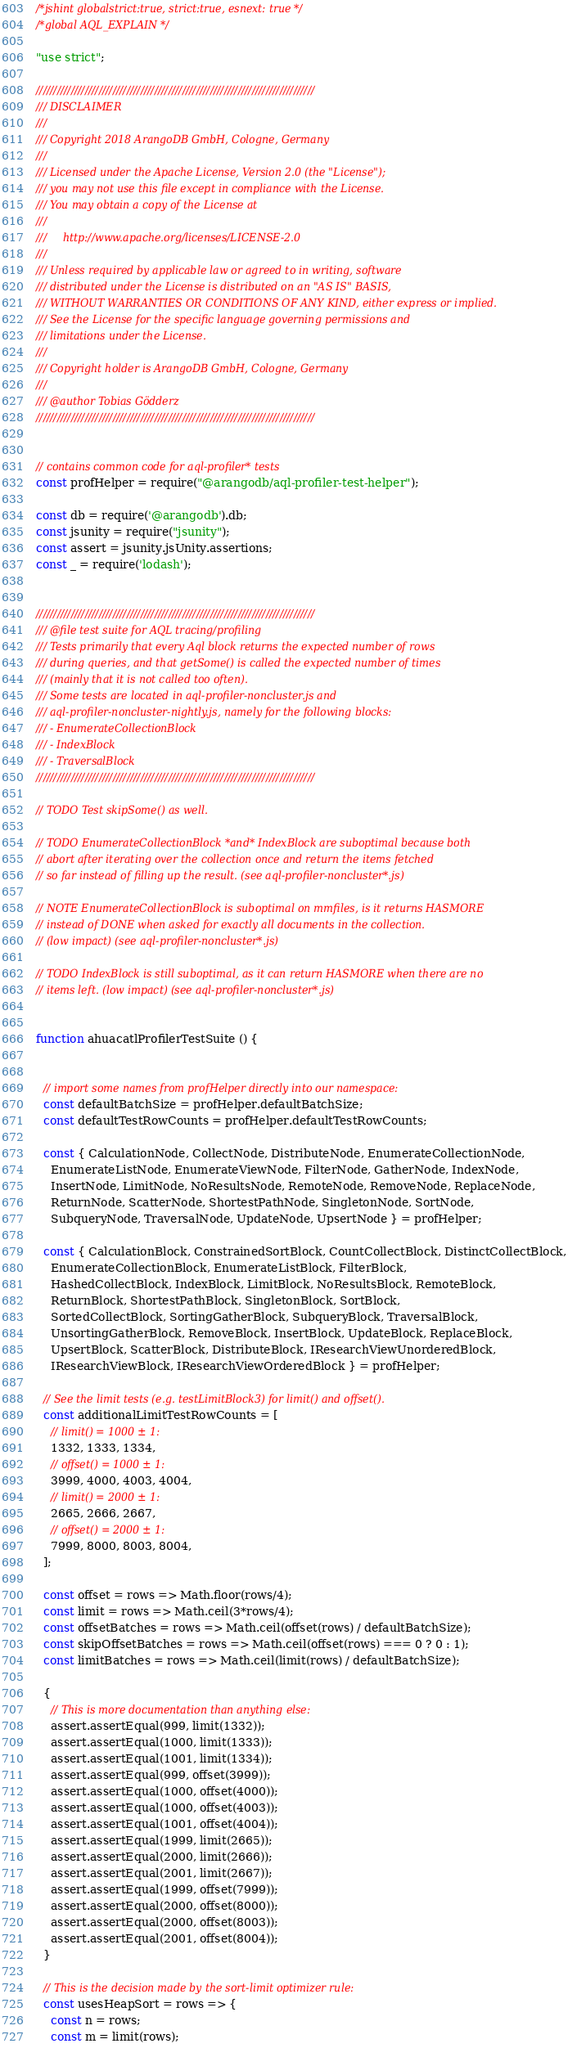Convert code to text. <code><loc_0><loc_0><loc_500><loc_500><_JavaScript_>/*jshint globalstrict:true, strict:true, esnext: true */
/*global AQL_EXPLAIN */

"use strict";

////////////////////////////////////////////////////////////////////////////////
/// DISCLAIMER
///
/// Copyright 2018 ArangoDB GmbH, Cologne, Germany
///
/// Licensed under the Apache License, Version 2.0 (the "License");
/// you may not use this file except in compliance with the License.
/// You may obtain a copy of the License at
///
///     http://www.apache.org/licenses/LICENSE-2.0
///
/// Unless required by applicable law or agreed to in writing, software
/// distributed under the License is distributed on an "AS IS" BASIS,
/// WITHOUT WARRANTIES OR CONDITIONS OF ANY KIND, either express or implied.
/// See the License for the specific language governing permissions and
/// limitations under the License.
///
/// Copyright holder is ArangoDB GmbH, Cologne, Germany
///
/// @author Tobias Gödderz
////////////////////////////////////////////////////////////////////////////////


// contains common code for aql-profiler* tests
const profHelper = require("@arangodb/aql-profiler-test-helper");

const db = require('@arangodb').db;
const jsunity = require("jsunity");
const assert = jsunity.jsUnity.assertions;
const _ = require('lodash');


////////////////////////////////////////////////////////////////////////////////
/// @file test suite for AQL tracing/profiling
/// Tests primarily that every Aql block returns the expected number of rows
/// during queries, and that getSome() is called the expected number of times
/// (mainly that it is not called too often).
/// Some tests are located in aql-profiler-noncluster.js and
/// aql-profiler-noncluster-nightly.js, namely for the following blocks:
/// - EnumerateCollectionBlock
/// - IndexBlock
/// - TraversalBlock
////////////////////////////////////////////////////////////////////////////////

// TODO Test skipSome() as well.

// TODO EnumerateCollectionBlock *and* IndexBlock are suboptimal because both
// abort after iterating over the collection once and return the items fetched
// so far instead of filling up the result. (see aql-profiler-noncluster*.js)

// NOTE EnumerateCollectionBlock is suboptimal on mmfiles, is it returns HASMORE
// instead of DONE when asked for exactly all documents in the collection.
// (low impact) (see aql-profiler-noncluster*.js)

// TODO IndexBlock is still suboptimal, as it can return HASMORE when there are no
// items left. (low impact) (see aql-profiler-noncluster*.js)


function ahuacatlProfilerTestSuite () {


  // import some names from profHelper directly into our namespace:
  const defaultBatchSize = profHelper.defaultBatchSize;
  const defaultTestRowCounts = profHelper.defaultTestRowCounts;

  const { CalculationNode, CollectNode, DistributeNode, EnumerateCollectionNode,
    EnumerateListNode, EnumerateViewNode, FilterNode, GatherNode, IndexNode,
    InsertNode, LimitNode, NoResultsNode, RemoteNode, RemoveNode, ReplaceNode,
    ReturnNode, ScatterNode, ShortestPathNode, SingletonNode, SortNode,
    SubqueryNode, TraversalNode, UpdateNode, UpsertNode } = profHelper;

  const { CalculationBlock, ConstrainedSortBlock, CountCollectBlock, DistinctCollectBlock,
    EnumerateCollectionBlock, EnumerateListBlock, FilterBlock,
    HashedCollectBlock, IndexBlock, LimitBlock, NoResultsBlock, RemoteBlock,
    ReturnBlock, ShortestPathBlock, SingletonBlock, SortBlock,
    SortedCollectBlock, SortingGatherBlock, SubqueryBlock, TraversalBlock,
    UnsortingGatherBlock, RemoveBlock, InsertBlock, UpdateBlock, ReplaceBlock,
    UpsertBlock, ScatterBlock, DistributeBlock, IResearchViewUnorderedBlock,
    IResearchViewBlock, IResearchViewOrderedBlock } = profHelper;

  // See the limit tests (e.g. testLimitBlock3) for limit() and offset().
  const additionalLimitTestRowCounts = [
    // limit() = 1000 ± 1:
    1332, 1333, 1334,
    // offset() = 1000 ± 1:
    3999, 4000, 4003, 4004,
    // limit() = 2000 ± 1:
    2665, 2666, 2667,
    // offset() = 2000 ± 1:
    7999, 8000, 8003, 8004,
  ];

  const offset = rows => Math.floor(rows/4);
  const limit = rows => Math.ceil(3*rows/4);
  const offsetBatches = rows => Math.ceil(offset(rows) / defaultBatchSize);
  const skipOffsetBatches = rows => Math.ceil(offset(rows) === 0 ? 0 : 1);
  const limitBatches = rows => Math.ceil(limit(rows) / defaultBatchSize);

  {
    // This is more documentation than anything else:
    assert.assertEqual(999, limit(1332));
    assert.assertEqual(1000, limit(1333));
    assert.assertEqual(1001, limit(1334));
    assert.assertEqual(999, offset(3999));
    assert.assertEqual(1000, offset(4000));
    assert.assertEqual(1000, offset(4003));
    assert.assertEqual(1001, offset(4004));
    assert.assertEqual(1999, limit(2665));
    assert.assertEqual(2000, limit(2666));
    assert.assertEqual(2001, limit(2667));
    assert.assertEqual(1999, offset(7999));
    assert.assertEqual(2000, offset(8000));
    assert.assertEqual(2000, offset(8003));
    assert.assertEqual(2001, offset(8004));
  }

  // This is the decision made by the sort-limit optimizer rule:
  const usesHeapSort = rows => {
    const n = rows;
    const m = limit(rows);</code> 